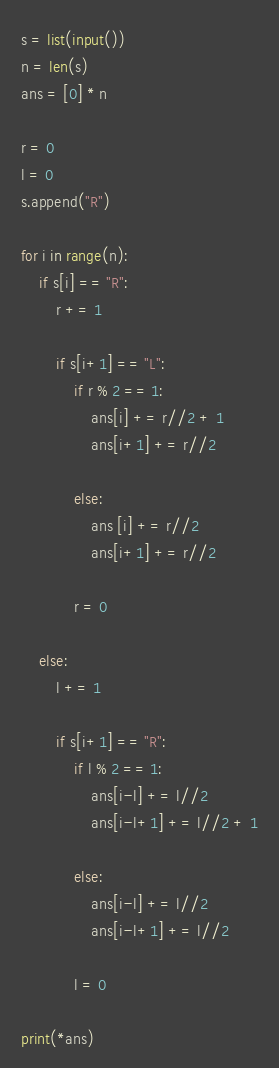Convert code to text. <code><loc_0><loc_0><loc_500><loc_500><_Python_>s = list(input())
n = len(s)
ans = [0] * n

r = 0
l = 0
s.append("R")

for i in range(n):
    if s[i] == "R":
        r += 1
        
        if s[i+1] == "L":
            if r % 2 == 1:
                ans[i] += r//2 + 1
                ans[i+1] += r//2
                
            else:
                ans [i] += r//2
                ans[i+1] += r//2
                
            r = 0
        
    else:
        l += 1
        
        if s[i+1] == "R":
            if l % 2 == 1:
                ans[i-l] += l//2
                ans[i-l+1] += l//2 + 1
                
            else:
                ans[i-l] += l//2
                ans[i-l+1] += l//2
                
            l = 0
            
print(*ans)</code> 